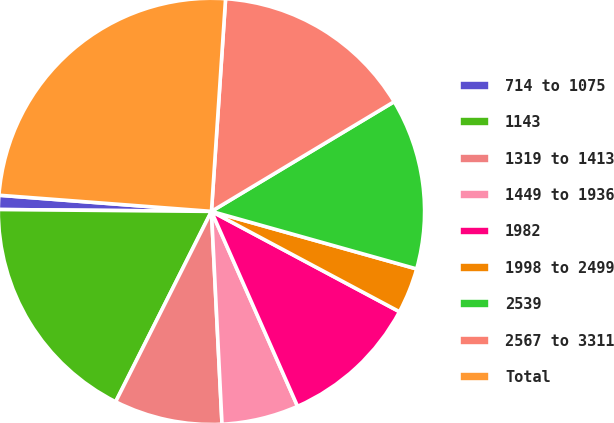<chart> <loc_0><loc_0><loc_500><loc_500><pie_chart><fcel>714 to 1075<fcel>1143<fcel>1319 to 1413<fcel>1449 to 1936<fcel>1982<fcel>1998 to 2499<fcel>2539<fcel>2567 to 3311<fcel>Total<nl><fcel>1.07%<fcel>17.72%<fcel>8.21%<fcel>5.83%<fcel>10.58%<fcel>3.45%<fcel>12.96%<fcel>15.34%<fcel>24.85%<nl></chart> 